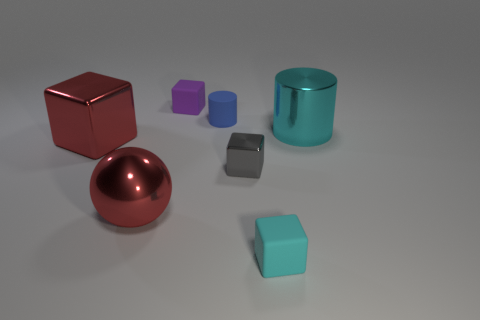Is the small cylinder made of the same material as the gray object?
Offer a terse response. No. What size is the red object that is the same shape as the small purple object?
Your answer should be compact. Large. There is a matte object that is behind the rubber cylinder; is its shape the same as the tiny thing that is to the right of the gray object?
Your answer should be compact. Yes. Is the size of the rubber cylinder the same as the metallic cube in front of the large red metal cube?
Your response must be concise. Yes. How many other things are made of the same material as the blue thing?
Offer a very short reply. 2. Is there anything else that is the same shape as the tiny gray metallic thing?
Your answer should be compact. Yes. There is a small matte cube in front of the big object that is on the right side of the cyan object in front of the small gray thing; what is its color?
Your response must be concise. Cyan. There is a big thing that is both left of the tiny blue rubber thing and to the right of the red metal cube; what shape is it?
Provide a succinct answer. Sphere. Is there anything else that is the same size as the gray cube?
Give a very brief answer. Yes. There is a big thing right of the tiny rubber block left of the gray block; what is its color?
Your answer should be very brief. Cyan. 